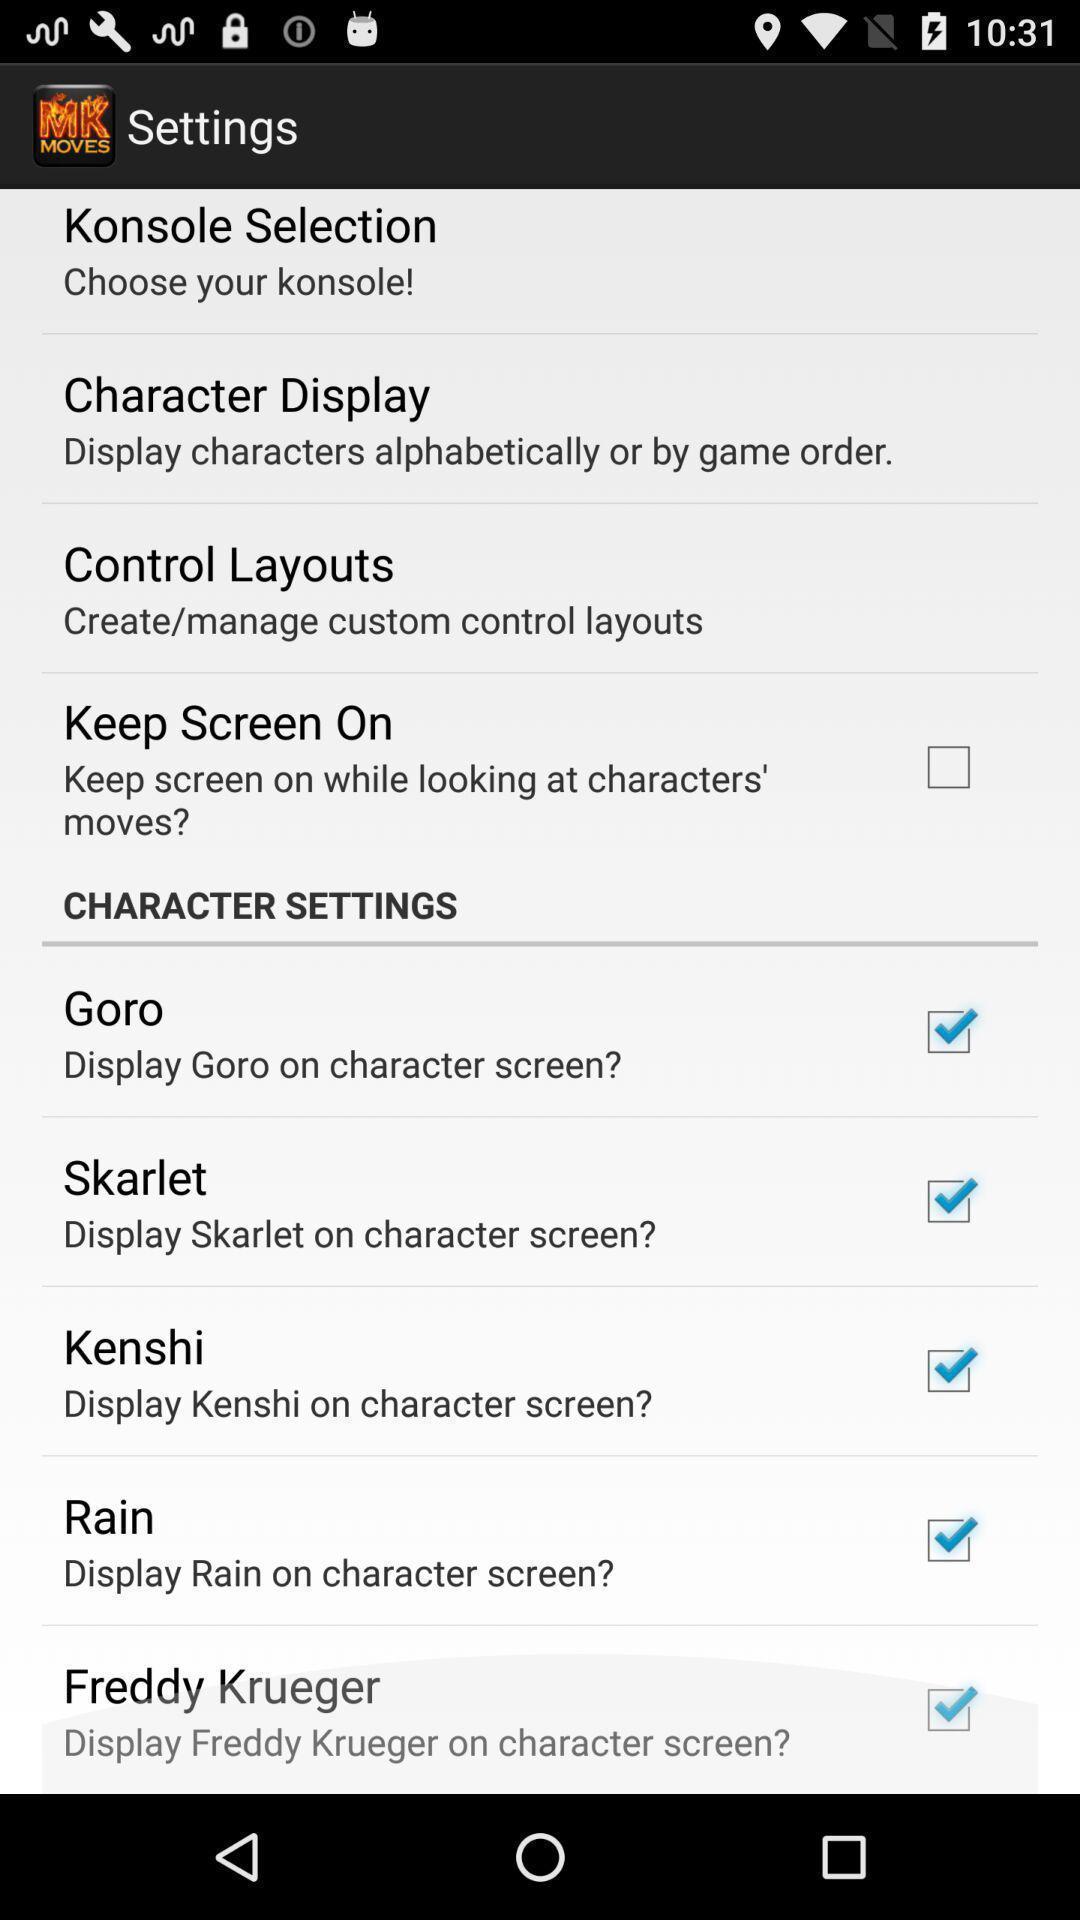What is the overall content of this screenshot? Settings page displayed. 